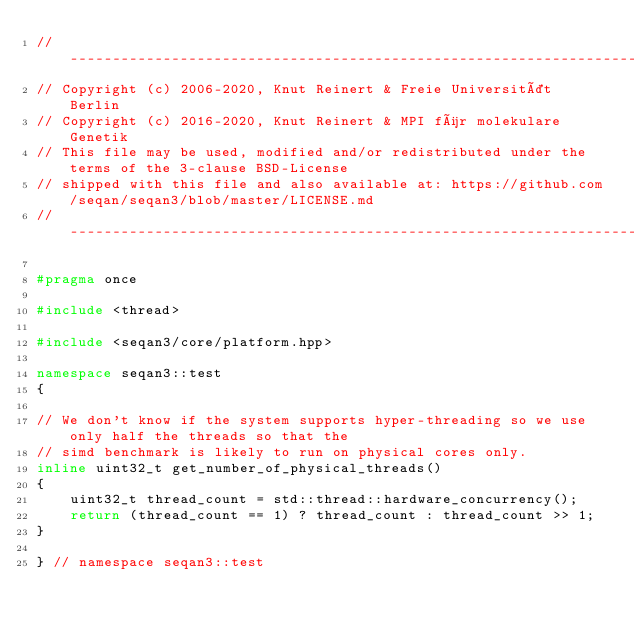Convert code to text. <code><loc_0><loc_0><loc_500><loc_500><_C++_>// -----------------------------------------------------------------------------------------------------
// Copyright (c) 2006-2020, Knut Reinert & Freie Universität Berlin
// Copyright (c) 2016-2020, Knut Reinert & MPI für molekulare Genetik
// This file may be used, modified and/or redistributed under the terms of the 3-clause BSD-License
// shipped with this file and also available at: https://github.com/seqan/seqan3/blob/master/LICENSE.md
// -----------------------------------------------------------------------------------------------------

#pragma once

#include <thread>

#include <seqan3/core/platform.hpp>

namespace seqan3::test
{

// We don't know if the system supports hyper-threading so we use only half the threads so that the
// simd benchmark is likely to run on physical cores only.
inline uint32_t get_number_of_physical_threads()
{
    uint32_t thread_count = std::thread::hardware_concurrency();
    return (thread_count == 1) ? thread_count : thread_count >> 1;
}

} // namespace seqan3::test
</code> 